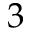Convert formula to latex. <formula><loc_0><loc_0><loc_500><loc_500>3</formula> 